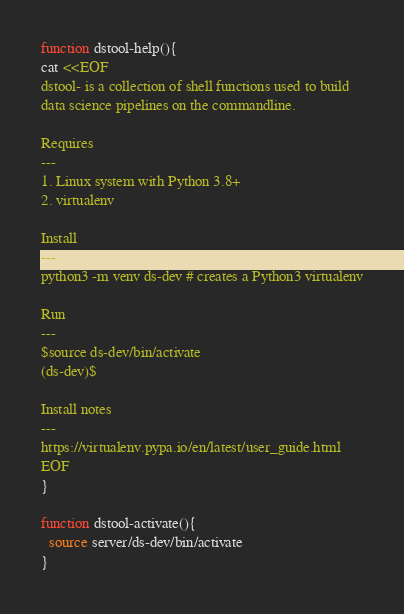Convert code to text. <code><loc_0><loc_0><loc_500><loc_500><_Bash_>function dstool-help(){
cat <<EOF
dstool- is a collection of shell functions used to build 
data science pipelines on the commandline.

Requires
---
1. Linux system with Python 3.8+
2. virtualenv

Install
---
python3 -m venv ds-dev # creates a Python3 virtualenv

Run
---
$source ds-dev/bin/activate
(ds-dev)$ 

Install notes
---
https://virtualenv.pypa.io/en/latest/user_guide.html
EOF
}

function dstool-activate(){
  source server/ds-dev/bin/activate
}
</code> 